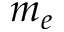<formula> <loc_0><loc_0><loc_500><loc_500>m _ { e }</formula> 